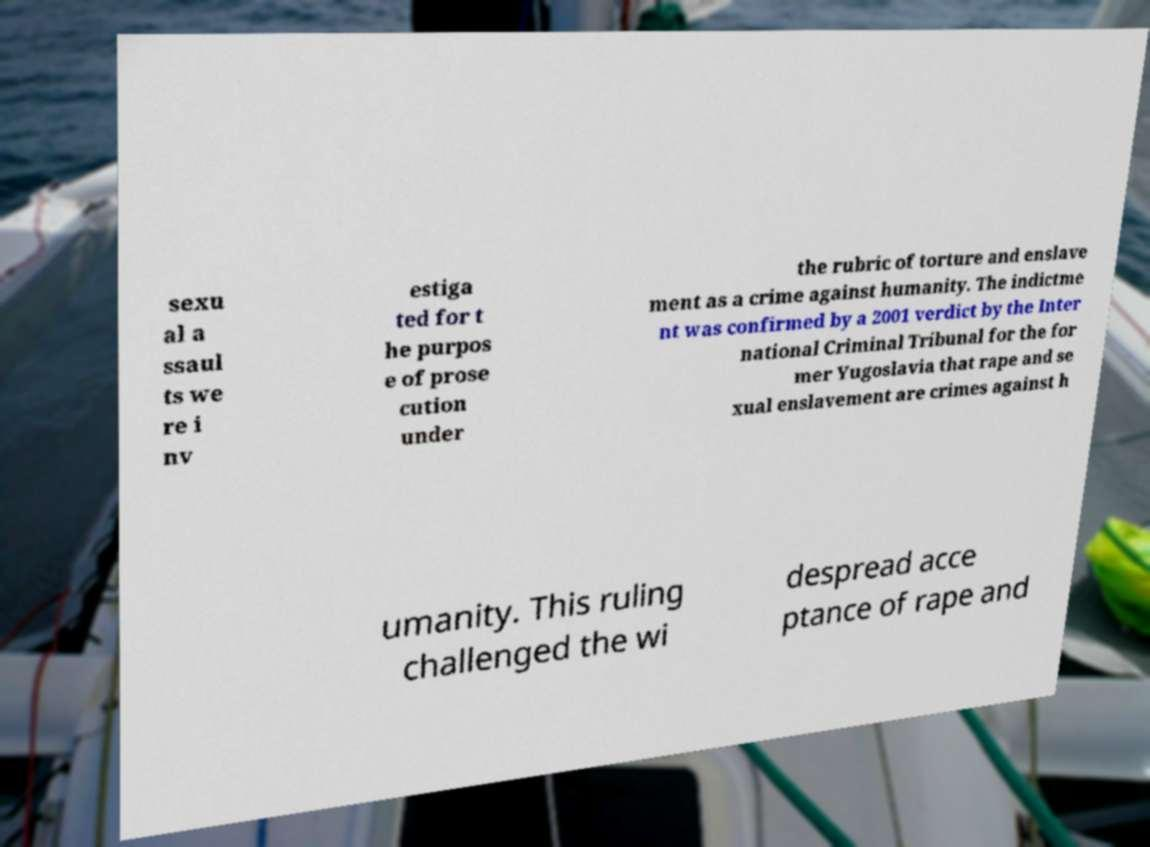I need the written content from this picture converted into text. Can you do that? sexu al a ssaul ts we re i nv estiga ted for t he purpos e of prose cution under the rubric of torture and enslave ment as a crime against humanity. The indictme nt was confirmed by a 2001 verdict by the Inter national Criminal Tribunal for the for mer Yugoslavia that rape and se xual enslavement are crimes against h umanity. This ruling challenged the wi despread acce ptance of rape and 